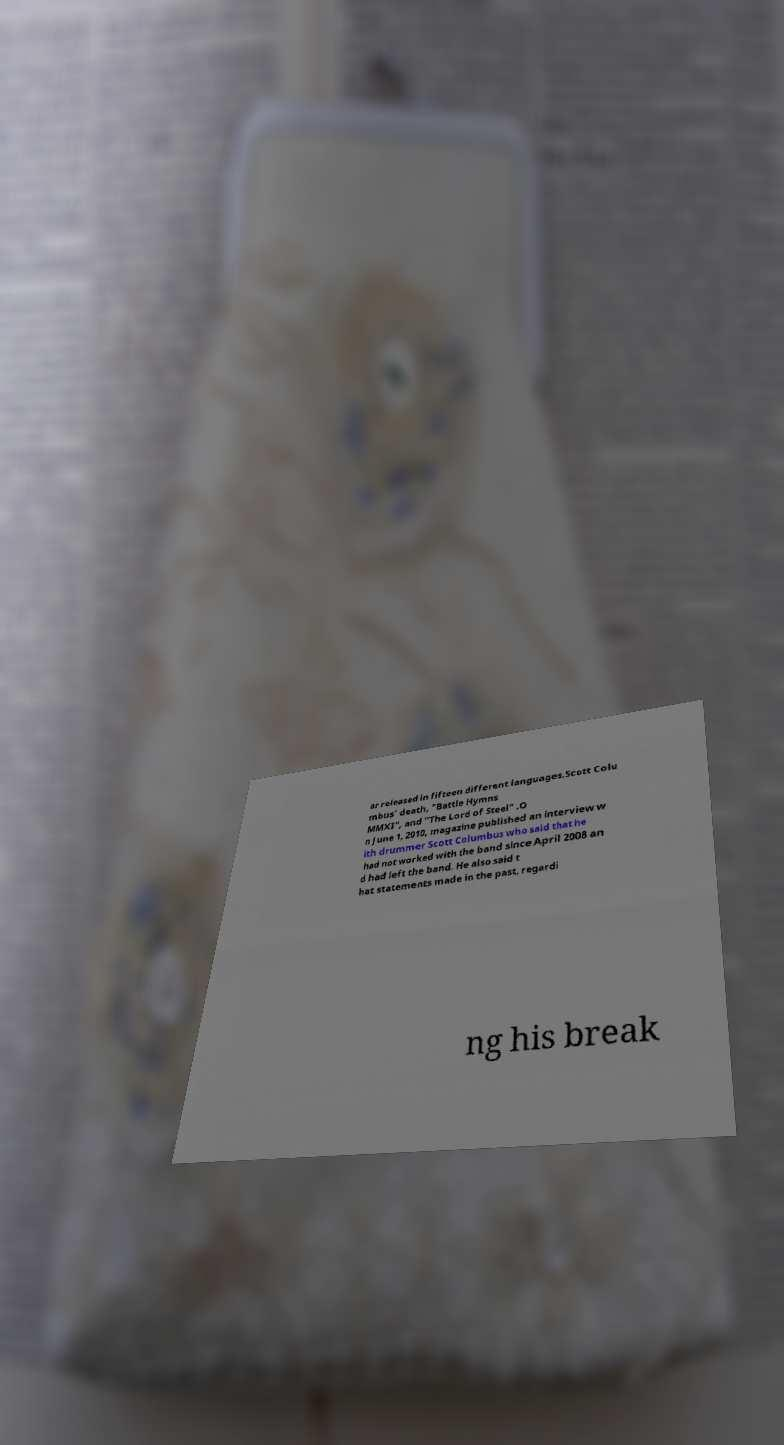Please identify and transcribe the text found in this image. ar released in fifteen different languages.Scott Colu mbus' death, "Battle Hymns MMXI", and "The Lord of Steel" .O n June 1, 2010, magazine published an interview w ith drummer Scott Columbus who said that he had not worked with the band since April 2008 an d had left the band. He also said t hat statements made in the past, regardi ng his break 